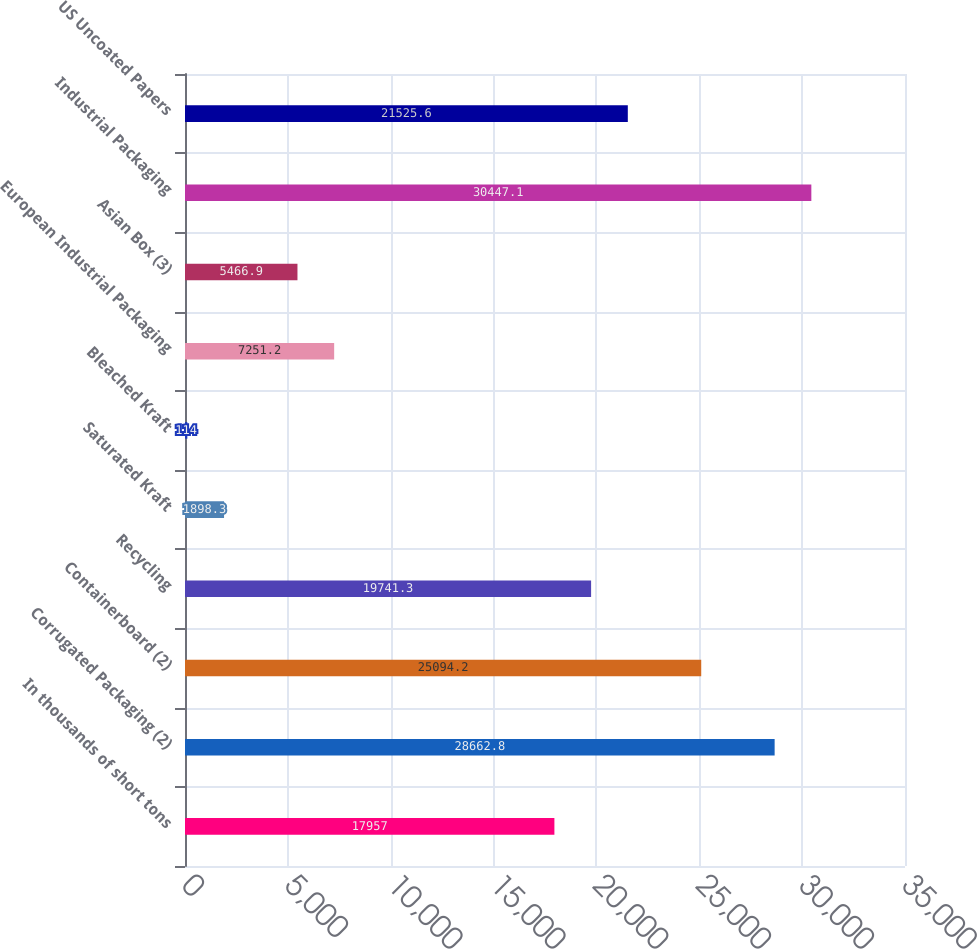Convert chart. <chart><loc_0><loc_0><loc_500><loc_500><bar_chart><fcel>In thousands of short tons<fcel>Corrugated Packaging (2)<fcel>Containerboard (2)<fcel>Recycling<fcel>Saturated Kraft<fcel>Bleached Kraft<fcel>European Industrial Packaging<fcel>Asian Box (3)<fcel>Industrial Packaging<fcel>US Uncoated Papers<nl><fcel>17957<fcel>28662.8<fcel>25094.2<fcel>19741.3<fcel>1898.3<fcel>114<fcel>7251.2<fcel>5466.9<fcel>30447.1<fcel>21525.6<nl></chart> 